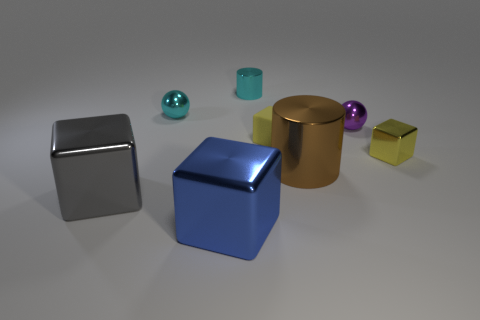Is the number of yellow rubber blocks greater than the number of large purple metallic things?
Keep it short and to the point. Yes. Does the metal block that is on the right side of the cyan cylinder have the same size as the brown shiny thing?
Make the answer very short. No. What number of tiny metallic objects have the same color as the matte block?
Keep it short and to the point. 1. Does the large gray thing have the same shape as the matte thing?
Offer a very short reply. Yes. The blue metal object that is the same shape as the big gray object is what size?
Your answer should be very brief. Large. Is the number of metallic cylinders left of the big metallic cylinder greater than the number of big blue metallic objects right of the purple sphere?
Offer a very short reply. Yes. Are the large gray block and the big object in front of the big gray metal thing made of the same material?
Provide a short and direct response. Yes. There is a shiny thing that is behind the yellow metallic object and right of the large brown metal cylinder; what color is it?
Offer a terse response. Purple. There is a small yellow object to the left of the big brown shiny thing; what shape is it?
Make the answer very short. Cube. What is the size of the block left of the large thing that is in front of the big metal cube left of the big blue shiny cube?
Your answer should be compact. Large. 